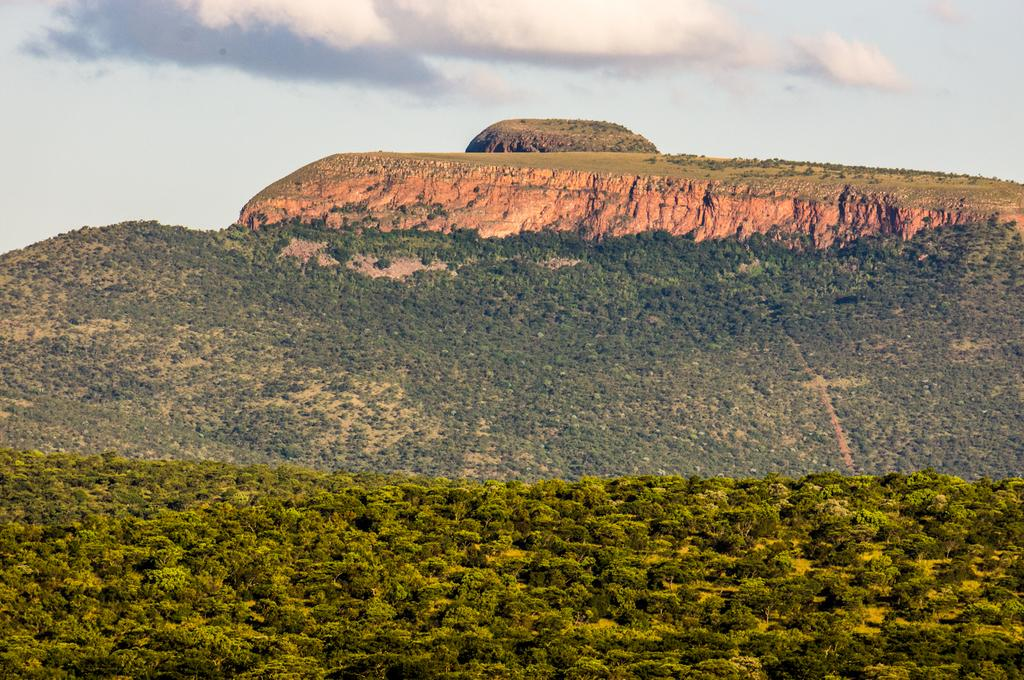What is the main geographical feature in the picture? There is a mountain in the picture. What type of vegetation can be seen in the foreground of the picture? There are trees in the foreground of the picture. What type of vegetation can be seen in the middle of the picture? There are trees in the middle of the picture. What is visible at the top of the picture? The sky is visible at the top of the picture. What type of sheet is draped over the mountain in the picture? There is no sheet present in the picture; it features a mountain, trees, and the sky. Can you see the friend of the mountain in the picture? There is no friend of the mountain present in the picture; it only features the mountain, trees, and the sky. 